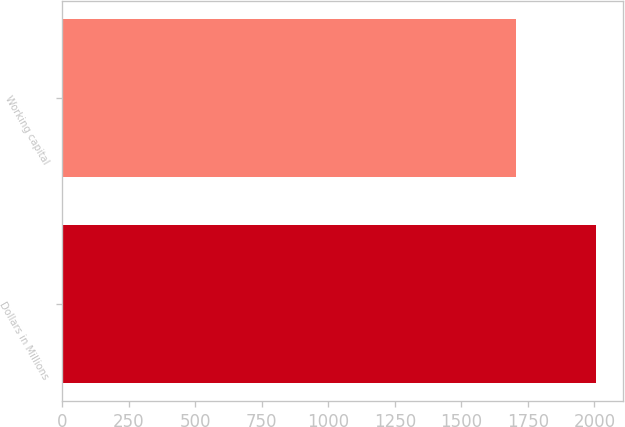<chart> <loc_0><loc_0><loc_500><loc_500><bar_chart><fcel>Dollars in Millions<fcel>Working capital<nl><fcel>2007<fcel>1704<nl></chart> 